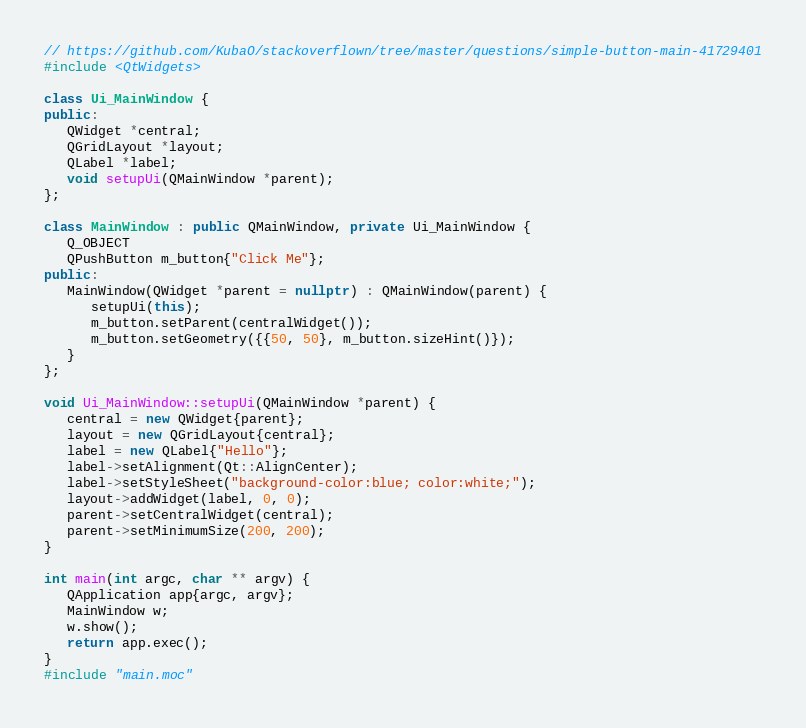Convert code to text. <code><loc_0><loc_0><loc_500><loc_500><_C++_>// https://github.com/KubaO/stackoverflown/tree/master/questions/simple-button-main-41729401
#include <QtWidgets>

class Ui_MainWindow {
public:
   QWidget *central;
   QGridLayout *layout;
   QLabel *label;
   void setupUi(QMainWindow *parent);
};

class MainWindow : public QMainWindow, private Ui_MainWindow {
   Q_OBJECT
   QPushButton m_button{"Click Me"};
public:
   MainWindow(QWidget *parent = nullptr) : QMainWindow(parent) {
      setupUi(this);
      m_button.setParent(centralWidget());
      m_button.setGeometry({{50, 50}, m_button.sizeHint()});
   }
};

void Ui_MainWindow::setupUi(QMainWindow *parent) {
   central = new QWidget{parent};
   layout = new QGridLayout{central};
   label = new QLabel{"Hello"};
   label->setAlignment(Qt::AlignCenter);
   label->setStyleSheet("background-color:blue; color:white;");
   layout->addWidget(label, 0, 0);
   parent->setCentralWidget(central);
   parent->setMinimumSize(200, 200);
}

int main(int argc, char ** argv) {
   QApplication app{argc, argv};
   MainWindow w;
   w.show();
   return app.exec();
}
#include "main.moc"
</code> 